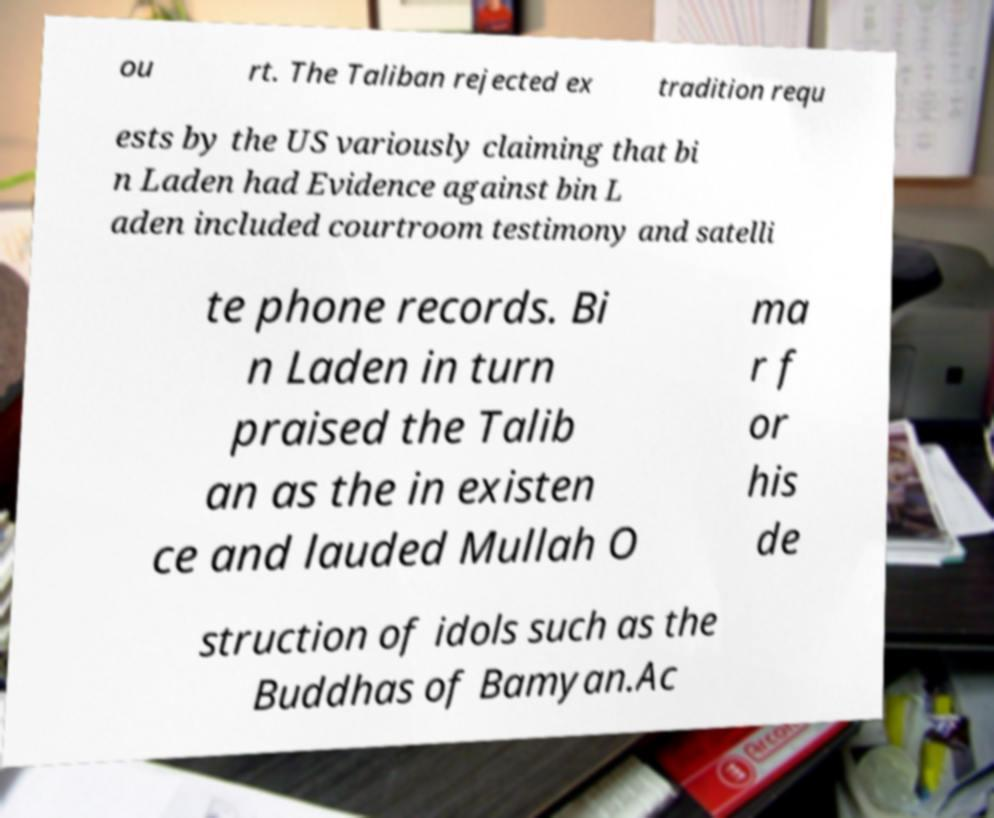For documentation purposes, I need the text within this image transcribed. Could you provide that? ou rt. The Taliban rejected ex tradition requ ests by the US variously claiming that bi n Laden had Evidence against bin L aden included courtroom testimony and satelli te phone records. Bi n Laden in turn praised the Talib an as the in existen ce and lauded Mullah O ma r f or his de struction of idols such as the Buddhas of Bamyan.Ac 